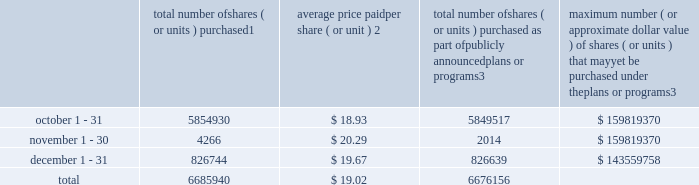Transfer agent and registrar for common stock the transfer agent and registrar for our common stock is : computershare shareowner services llc 480 washington boulevard 29th floor jersey city , new jersey 07310 telephone : ( 877 ) 363-6398 sales of unregistered securities not applicable .
Repurchase of equity securities the table provides information regarding our purchases of our equity securities during the period from october 1 , 2014 to december 31 , 2014 .
Total number of shares ( or units ) purchased 1 average price paid per share ( or unit ) 2 total number of shares ( or units ) purchased as part of publicly announced plans or programs 3 maximum number ( or approximate dollar value ) of shares ( or units ) that may yet be purchased under the plans or programs 3 .
1 included shares of our common stock , par value $ 0.10 per share , withheld under the terms of grants under employee stock-based compensation plans to offset tax withholding obligations that occurred upon vesting and release of restricted shares ( the 201cwithheld shares 201d ) .
We repurchased 5413 withheld shares in october 2014 , 4266 withheld shares in november 2014 and 105 withheld shares in december 2014 .
2 the average price per share for each of the months in the fiscal quarter and for the three-month period was calculated by dividing the sum of the applicable period of the aggregate value of the tax withholding obligations and the aggregate amount we paid for shares acquired under our stock repurchase program , described in note 5 to the consolidated financial statements , by the sum of the number of withheld shares and the number of shares acquired in our stock repurchase program .
3 in february 2014 , the board authorized a new share repurchase program to repurchase from time to time up to $ 300.0 million , excluding fees , of our common stock ( the 201c2014 share repurchase program 201d ) .
On february 13 , 2015 , we announced that our board had approved a new share repurchase program to repurchase from time to time up to $ 300.0 million , excluding fees , of our common stock .
The new authorization is in addition to any amounts remaining available for repurchase under the 2014 share repurchase program .
There is no expiration date associated with the share repurchase programs. .
What was the percentage decrease between total number of shares purchased in october and november? 
Computations: (((5854930 - 4266) / 5854930) * 100)
Answer: 99.92714. Transfer agent and registrar for common stock the transfer agent and registrar for our common stock is : computershare shareowner services llc 480 washington boulevard 29th floor jersey city , new jersey 07310 telephone : ( 877 ) 363-6398 sales of unregistered securities not applicable .
Repurchase of equity securities the table provides information regarding our purchases of our equity securities during the period from october 1 , 2014 to december 31 , 2014 .
Total number of shares ( or units ) purchased 1 average price paid per share ( or unit ) 2 total number of shares ( or units ) purchased as part of publicly announced plans or programs 3 maximum number ( or approximate dollar value ) of shares ( or units ) that may yet be purchased under the plans or programs 3 .
1 included shares of our common stock , par value $ 0.10 per share , withheld under the terms of grants under employee stock-based compensation plans to offset tax withholding obligations that occurred upon vesting and release of restricted shares ( the 201cwithheld shares 201d ) .
We repurchased 5413 withheld shares in october 2014 , 4266 withheld shares in november 2014 and 105 withheld shares in december 2014 .
2 the average price per share for each of the months in the fiscal quarter and for the three-month period was calculated by dividing the sum of the applicable period of the aggregate value of the tax withholding obligations and the aggregate amount we paid for shares acquired under our stock repurchase program , described in note 5 to the consolidated financial statements , by the sum of the number of withheld shares and the number of shares acquired in our stock repurchase program .
3 in february 2014 , the board authorized a new share repurchase program to repurchase from time to time up to $ 300.0 million , excluding fees , of our common stock ( the 201c2014 share repurchase program 201d ) .
On february 13 , 2015 , we announced that our board had approved a new share repurchase program to repurchase from time to time up to $ 300.0 million , excluding fees , of our common stock .
The new authorization is in addition to any amounts remaining available for repurchase under the 2014 share repurchase program .
There is no expiration date associated with the share repurchase programs. .
What was the total amount of share repurchase authorized in 2015 and 2014 by the board in milions? 
Computations: (300.0 + 300.0)
Answer: 600.0. 